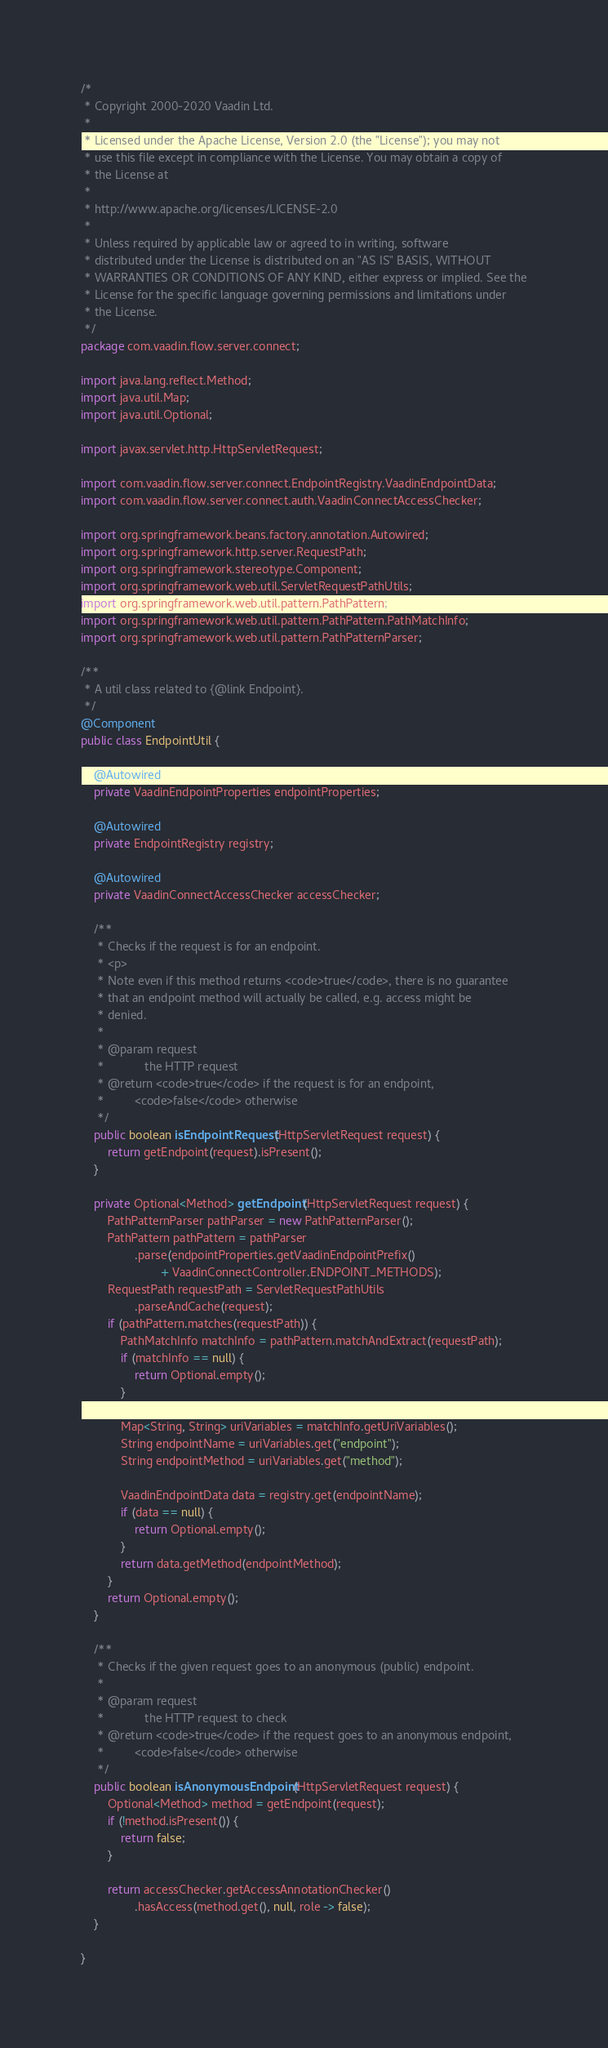<code> <loc_0><loc_0><loc_500><loc_500><_Java_>/*
 * Copyright 2000-2020 Vaadin Ltd.
 *
 * Licensed under the Apache License, Version 2.0 (the "License"); you may not
 * use this file except in compliance with the License. You may obtain a copy of
 * the License at
 *
 * http://www.apache.org/licenses/LICENSE-2.0
 *
 * Unless required by applicable law or agreed to in writing, software
 * distributed under the License is distributed on an "AS IS" BASIS, WITHOUT
 * WARRANTIES OR CONDITIONS OF ANY KIND, either express or implied. See the
 * License for the specific language governing permissions and limitations under
 * the License.
 */
package com.vaadin.flow.server.connect;

import java.lang.reflect.Method;
import java.util.Map;
import java.util.Optional;

import javax.servlet.http.HttpServletRequest;

import com.vaadin.flow.server.connect.EndpointRegistry.VaadinEndpointData;
import com.vaadin.flow.server.connect.auth.VaadinConnectAccessChecker;

import org.springframework.beans.factory.annotation.Autowired;
import org.springframework.http.server.RequestPath;
import org.springframework.stereotype.Component;
import org.springframework.web.util.ServletRequestPathUtils;
import org.springframework.web.util.pattern.PathPattern;
import org.springframework.web.util.pattern.PathPattern.PathMatchInfo;
import org.springframework.web.util.pattern.PathPatternParser;

/**
 * A util class related to {@link Endpoint}.
 */
@Component
public class EndpointUtil {

    @Autowired
    private VaadinEndpointProperties endpointProperties;

    @Autowired
    private EndpointRegistry registry;

    @Autowired
    private VaadinConnectAccessChecker accessChecker;

    /**
     * Checks if the request is for an endpoint.
     * <p>
     * Note even if this method returns <code>true</code>, there is no guarantee
     * that an endpoint method will actually be called, e.g. access might be
     * denied.
     *
     * @param request
     *            the HTTP request
     * @return <code>true</code> if the request is for an endpoint,
     *         <code>false</code> otherwise
     */
    public boolean isEndpointRequest(HttpServletRequest request) {
        return getEndpoint(request).isPresent();
    }

    private Optional<Method> getEndpoint(HttpServletRequest request) {
        PathPatternParser pathParser = new PathPatternParser();
        PathPattern pathPattern = pathParser
                .parse(endpointProperties.getVaadinEndpointPrefix()
                        + VaadinConnectController.ENDPOINT_METHODS);
        RequestPath requestPath = ServletRequestPathUtils
                .parseAndCache(request);
        if (pathPattern.matches(requestPath)) {
            PathMatchInfo matchInfo = pathPattern.matchAndExtract(requestPath);
            if (matchInfo == null) {
                return Optional.empty();
            }

            Map<String, String> uriVariables = matchInfo.getUriVariables();
            String endpointName = uriVariables.get("endpoint");
            String endpointMethod = uriVariables.get("method");

            VaadinEndpointData data = registry.get(endpointName);
            if (data == null) {
                return Optional.empty();
            }
            return data.getMethod(endpointMethod);
        }
        return Optional.empty();
    }

    /**
     * Checks if the given request goes to an anonymous (public) endpoint.
     * 
     * @param request
     *            the HTTP request to check
     * @return <code>true</code> if the request goes to an anonymous endpoint,
     *         <code>false</code> otherwise
     */
    public boolean isAnonymousEndpoint(HttpServletRequest request) {
        Optional<Method> method = getEndpoint(request);
        if (!method.isPresent()) {
            return false;
        }

        return accessChecker.getAccessAnnotationChecker()
                .hasAccess(method.get(), null, role -> false);
    }

}
</code> 